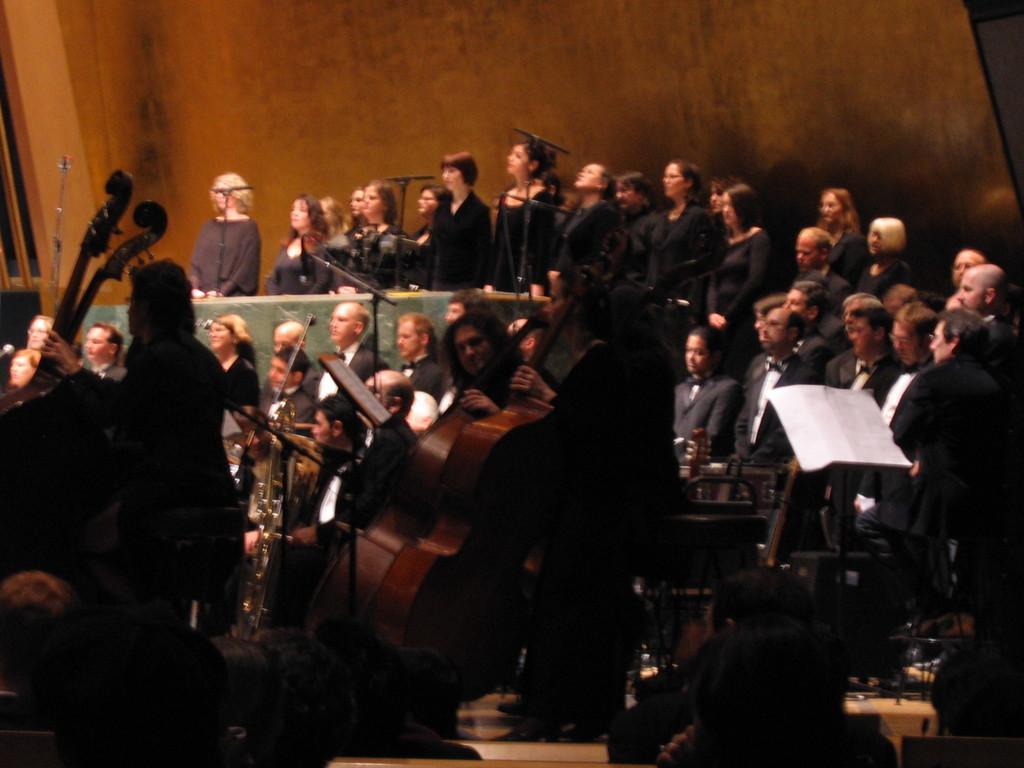Please provide a concise description of this image. In the background we can see the wooden wall. We can see people standing and few are playing musical instruments. On the right side we can see a white paper. 